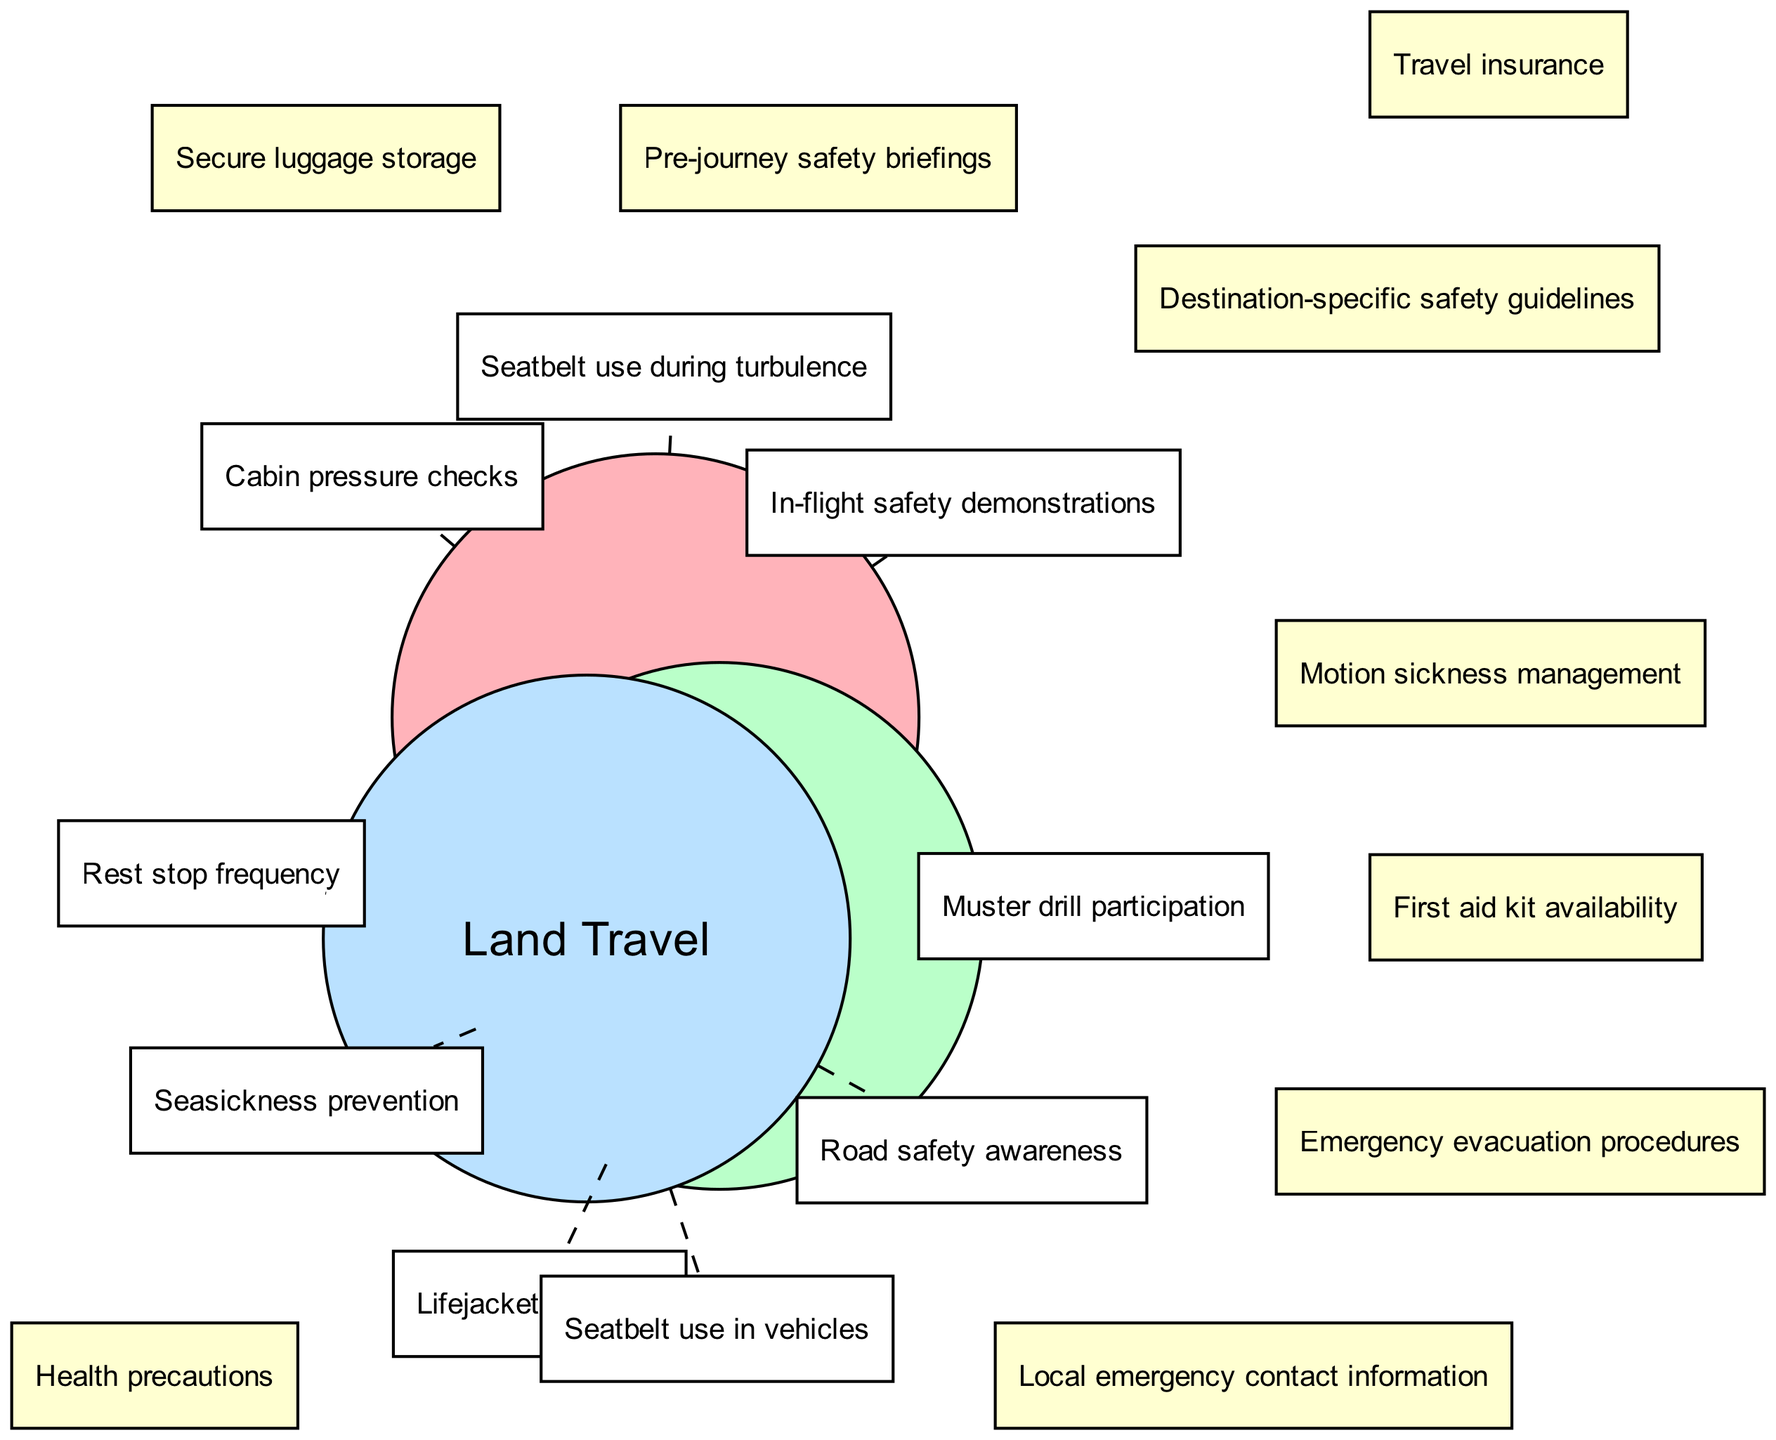What unique safety measure is associated with air travel? The diagram specifies "Cabin pressure checks" as a unique safety measure for air travel, which appears under the "Air Travel" circle.
Answer: Cabin pressure checks How many unique safety measures are listed for sea travel? Under the "Sea Travel" section, there are three unique safety measures: "Lifejacket locations," "Muster drill participation," and "Seasickness prevention." Therefore, the total count is three.
Answer: 3 What safety measures are shared between air travel and land travel? The intersection between "Air Travel" and "Land Travel" contains two shared safety measures: "Secure luggage storage" and "Pre-journey safety briefings."
Answer: Secure luggage storage, Pre-journey safety briefings Which safety measure is common to all three types of travel? The center intersection of the diagram, where all three circles overlap, shows that "Travel insurance," "Health precautions," and "Destination-specific safety guidelines" are common to air, sea, and land travel.
Answer: Travel insurance, Health precautions, Destination-specific safety guidelines What is a unique safety measure for land travel? The "Land Travel" circle includes "Seatbelt use in vehicles" as a unique safety measure, meaning it's specific to land travel without overlap with air or sea travel.
Answer: Seatbelt use in vehicles Which category has the most unique elements? By tallying the unique elements of each category, the "Air Travel" category has three unique elements, "Sea Travel" has three, and "Land Travel" also contains three. Since all have an equal count, it can be said that none has more than the others.
Answer: None What intersection safety measure is focused on emergency preparedness? The shared safety measures between "Air Travel" and "Sea Travel" include "Emergency evacuation procedures," indicating a focus on emergency preparedness in that intersection.
Answer: Emergency evacuation procedures What distinguishes the safety measures for sea travel compared to land travel? The unique elements in "Sea Travel" include "Lifejacket locations," "Muster drill participation," and "Seasickness prevention," which are distinctly related to maritime protocols, unlike land travel which focuses on road safety.
Answer: Lifejacket locations, Muster drill participation, Seasickness prevention 